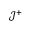Convert formula to latex. <formula><loc_0><loc_0><loc_500><loc_500>\mathcal { J } ^ { + }</formula> 